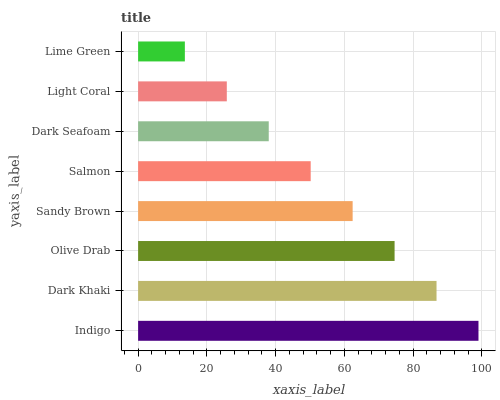Is Lime Green the minimum?
Answer yes or no. Yes. Is Indigo the maximum?
Answer yes or no. Yes. Is Dark Khaki the minimum?
Answer yes or no. No. Is Dark Khaki the maximum?
Answer yes or no. No. Is Indigo greater than Dark Khaki?
Answer yes or no. Yes. Is Dark Khaki less than Indigo?
Answer yes or no. Yes. Is Dark Khaki greater than Indigo?
Answer yes or no. No. Is Indigo less than Dark Khaki?
Answer yes or no. No. Is Sandy Brown the high median?
Answer yes or no. Yes. Is Salmon the low median?
Answer yes or no. Yes. Is Indigo the high median?
Answer yes or no. No. Is Dark Khaki the low median?
Answer yes or no. No. 